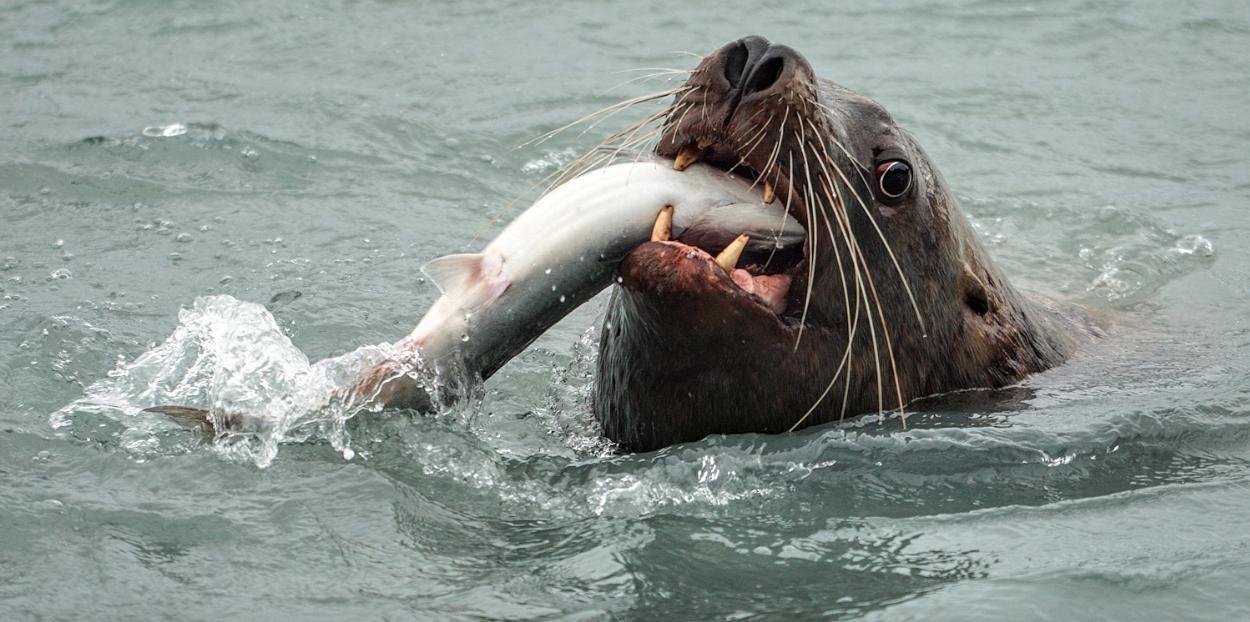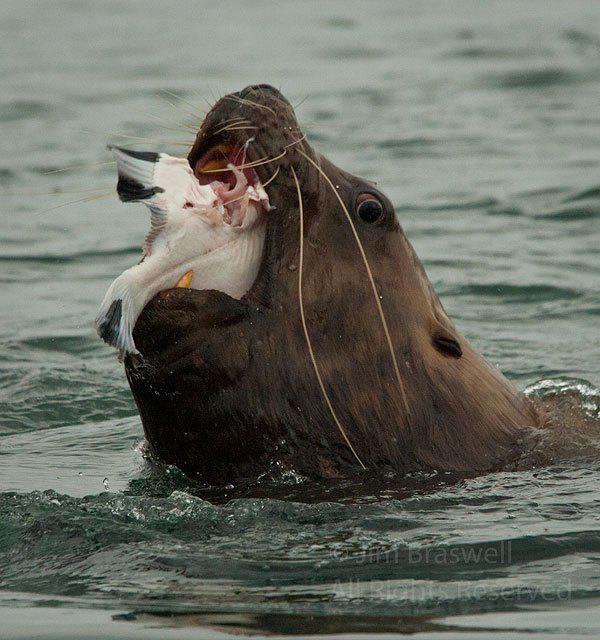The first image is the image on the left, the second image is the image on the right. Examine the images to the left and right. Is the description "Each image shows one seal with its head out of water and a fish caught in its mouth, and the seals in the left and right images face the same direction." accurate? Answer yes or no. Yes. 